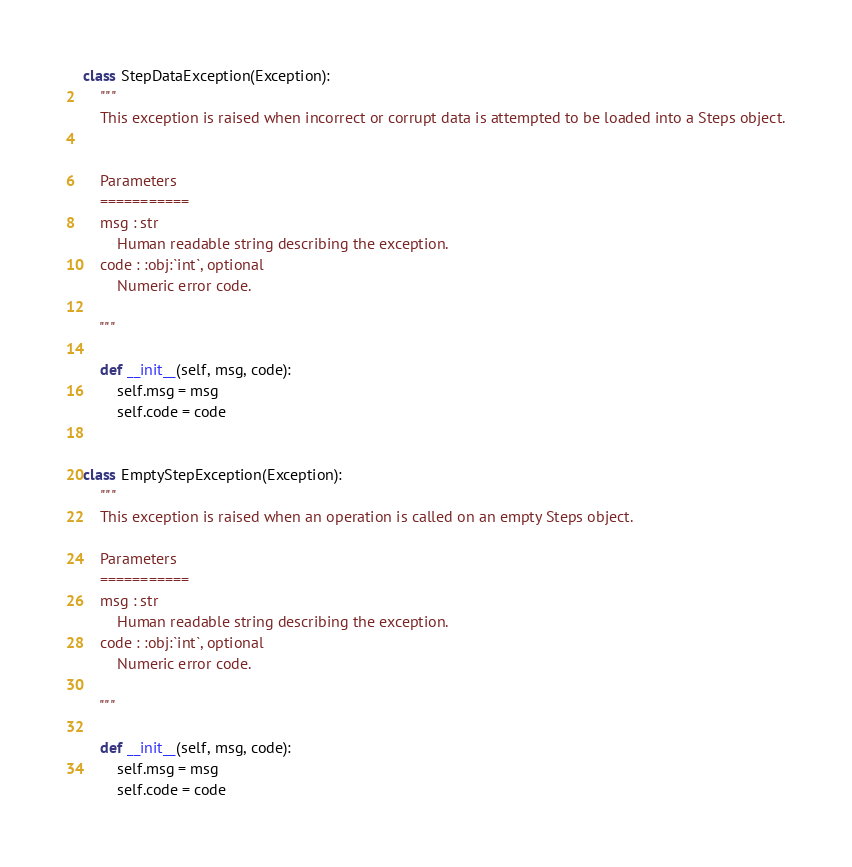Convert code to text. <code><loc_0><loc_0><loc_500><loc_500><_Python_>class StepDataException(Exception):
    """
    This exception is raised when incorrect or corrupt data is attempted to be loaded into a Steps object.


    Parameters
    ===========
    msg : str
        Human readable string describing the exception.
    code : :obj:`int`, optional
        Numeric error code.

    """

    def __init__(self, msg, code):
        self.msg = msg
        self.code = code


class EmptyStepException(Exception):
    """
    This exception is raised when an operation is called on an empty Steps object.

    Parameters
    ===========
    msg : str
        Human readable string describing the exception.
    code : :obj:`int`, optional
        Numeric error code.

    """

    def __init__(self, msg, code):
        self.msg = msg
        self.code = code</code> 